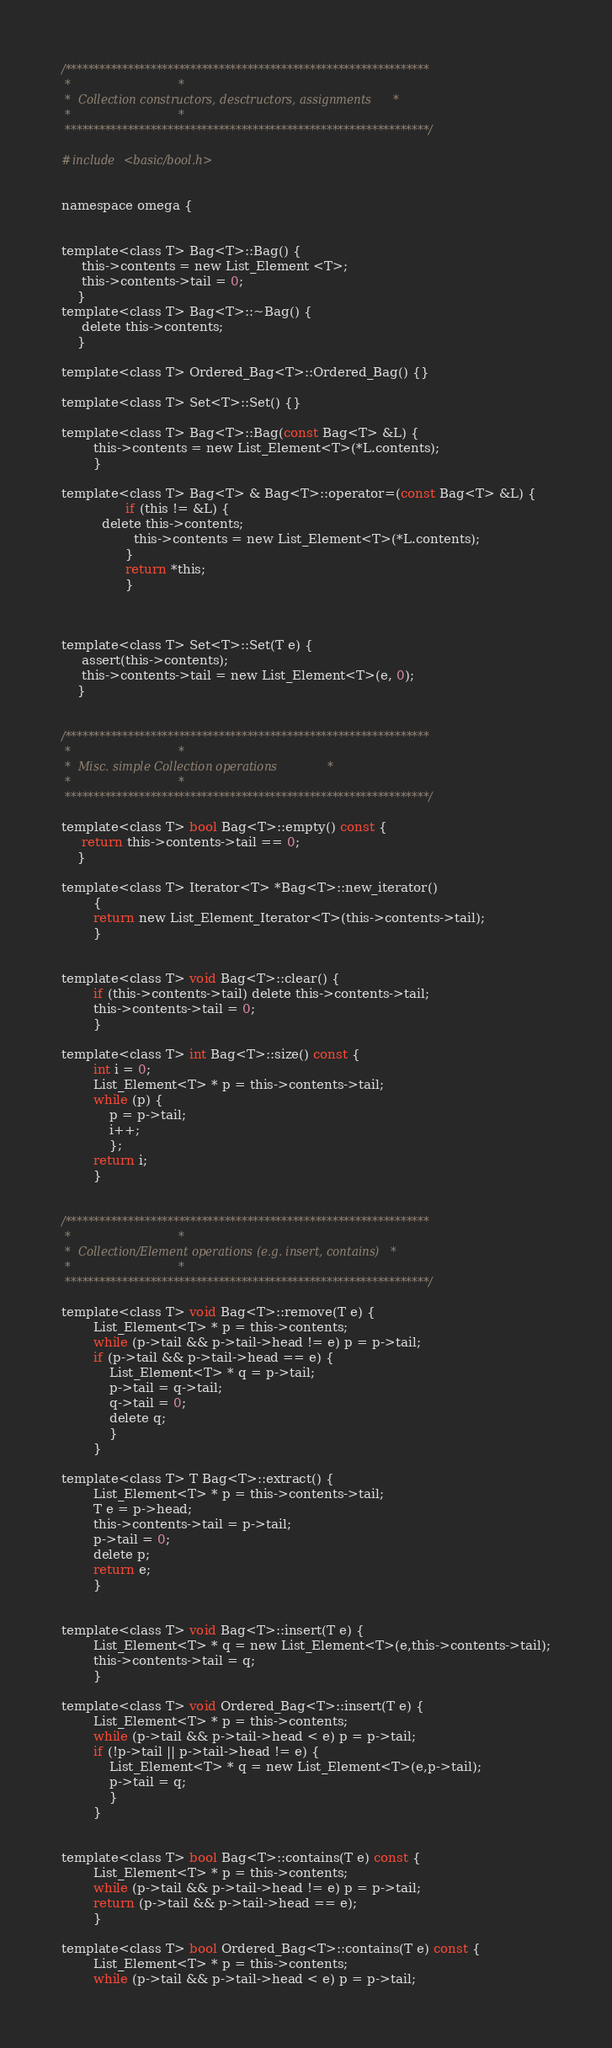<code> <loc_0><loc_0><loc_500><loc_500><_C_>/****************************************************************
 *								*
 *  Collection constructors, desctructors, assignments		*
 *								*
 ****************************************************************/

#include <basic/bool.h>


namespace omega {


template<class T> Bag<T>::Bag() {
	 this->contents = new List_Element <T>;
	 this->contents->tail = 0;
	}
template<class T> Bag<T>::~Bag() {
	 delete this->contents;
	}

template<class T> Ordered_Bag<T>::Ordered_Bag() {}

template<class T> Set<T>::Set() {}

template<class T> Bag<T>::Bag(const Bag<T> &L) {
		this->contents = new List_Element<T>(*L.contents);
		}

template<class T> Bag<T> & Bag<T>::operator=(const Bag<T> &L) {
                if (this != &L) {
		  delete this->contents;
                  this->contents = new List_Element<T>(*L.contents);
                }
                return *this;
                }



template<class T> Set<T>::Set(T e) {
	 assert(this->contents);
	 this->contents->tail = new List_Element<T>(e, 0);
	}
	

/****************************************************************
 *								*
 *  Misc. simple Collection operations 				*
 *								*
 ****************************************************************/

template<class T> bool Bag<T>::empty() const {
	 return this->contents->tail == 0;
	}

template<class T> Iterator<T> *Bag<T>::new_iterator()
		{
		return new List_Element_Iterator<T>(this->contents->tail);
		}


template<class T> void Bag<T>::clear() {
		if (this->contents->tail) delete this->contents->tail;
		this->contents->tail = 0;
		}

template<class T> int Bag<T>::size() const {
		int i = 0;
		List_Element<T> * p = this->contents->tail;
		while (p) {
			p = p->tail;
			i++;
			};
		return i;
		}


/****************************************************************
 *								*
 *  Collection/Element operations (e.g. insert, contains)	*
 *								*
 ****************************************************************/

template<class T> void Bag<T>::remove(T e) {
		List_Element<T> * p = this->contents;
		while (p->tail && p->tail->head != e) p = p->tail;
		if (p->tail && p->tail->head == e) {
			List_Element<T> * q = p->tail;
			p->tail = q->tail;
			q->tail = 0;
			delete q;
			}
		}

template<class T> T Bag<T>::extract() {
		List_Element<T> * p = this->contents->tail;
		T e = p->head;
		this->contents->tail = p->tail;
		p->tail = 0;
		delete p;
		return e;
		}


template<class T> void Bag<T>::insert(T e) {
		List_Element<T> * q = new List_Element<T>(e,this->contents->tail);
		this->contents->tail = q;
		}

template<class T> void Ordered_Bag<T>::insert(T e) {
		List_Element<T> * p = this->contents;
		while (p->tail && p->tail->head < e) p = p->tail;
		if (!p->tail || p->tail->head != e) {
			List_Element<T> * q = new List_Element<T>(e,p->tail);
			p->tail = q;
			}
		}


template<class T> bool Bag<T>::contains(T e) const {
		List_Element<T> * p = this->contents;
		while (p->tail && p->tail->head != e) p = p->tail;
		return (p->tail && p->tail->head == e);
		}

template<class T> bool Ordered_Bag<T>::contains(T e) const {
		List_Element<T> * p = this->contents;
		while (p->tail && p->tail->head < e) p = p->tail;</code> 